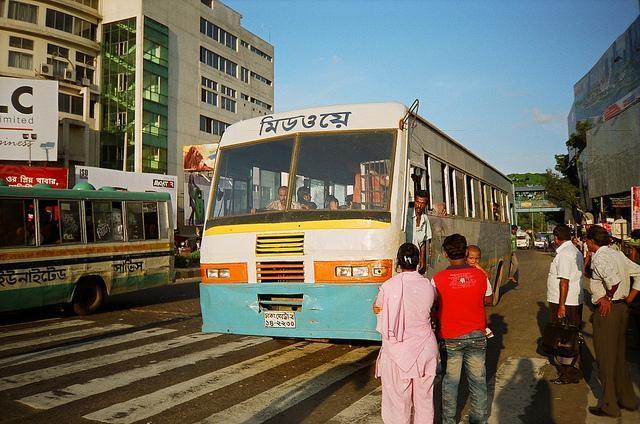How many buses are there?
Give a very brief answer. 2. How many people are there?
Give a very brief answer. 4. How many oranges can be seen in the bottom box?
Give a very brief answer. 0. 